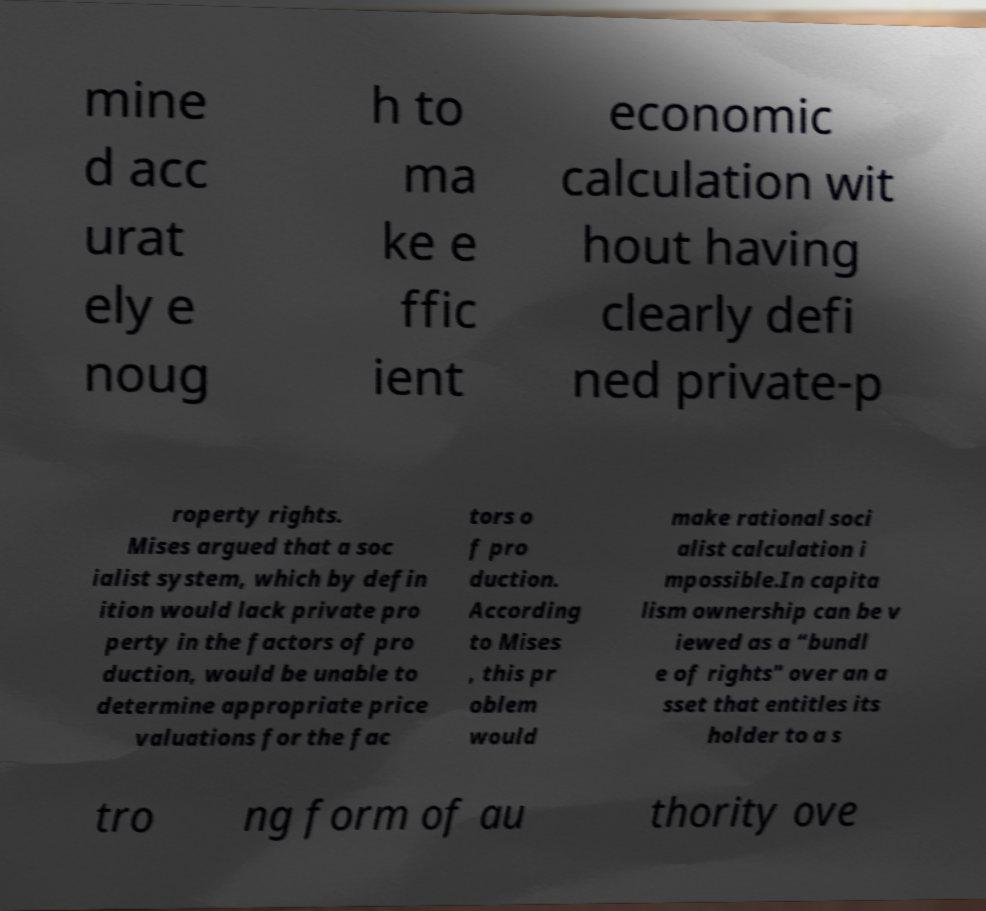Can you read and provide the text displayed in the image?This photo seems to have some interesting text. Can you extract and type it out for me? mine d acc urat ely e noug h to ma ke e ffic ient economic calculation wit hout having clearly defi ned private-p roperty rights. Mises argued that a soc ialist system, which by defin ition would lack private pro perty in the factors of pro duction, would be unable to determine appropriate price valuations for the fac tors o f pro duction. According to Mises , this pr oblem would make rational soci alist calculation i mpossible.In capita lism ownership can be v iewed as a “bundl e of rights" over an a sset that entitles its holder to a s tro ng form of au thority ove 